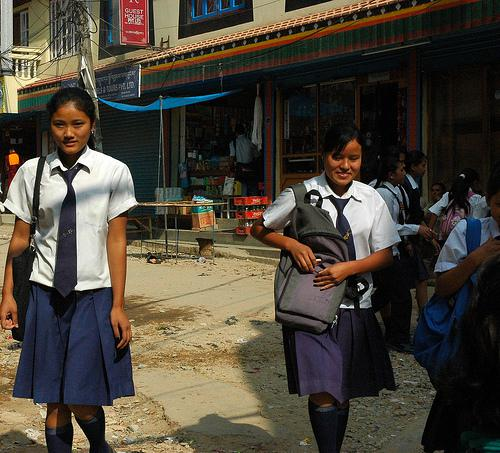Question: who is smiling?
Choices:
A. Man in front.
B. Boy with the hat on.
C. The whole family.
D. Girl on the right.
Answer with the letter. Answer: D Question: why is she smilling?
Choices:
A. She is happy.
B. She is getting her picture taken.
C. She just won the game.
D. She is happy to see him.
Answer with the letter. Answer: A Question: what is she carrying?
Choices:
A. A purse.
B. The baby.
C. A bag.
D. Her phone.
Answer with the letter. Answer: C Question: what is she wearing?
Choices:
A. A dress.
B. Socks.
C. Jeans.
D. Sandals.
Answer with the letter. Answer: B Question: what is the color of the tie?
Choices:
A. Navy blue.
B. Red.
C. Pink.
D. Green.
Answer with the letter. Answer: A Question: when was the pic taken?
Choices:
A. During the day.
B. At night.
C. In the morning.
D. Afternoon.
Answer with the letter. Answer: A 